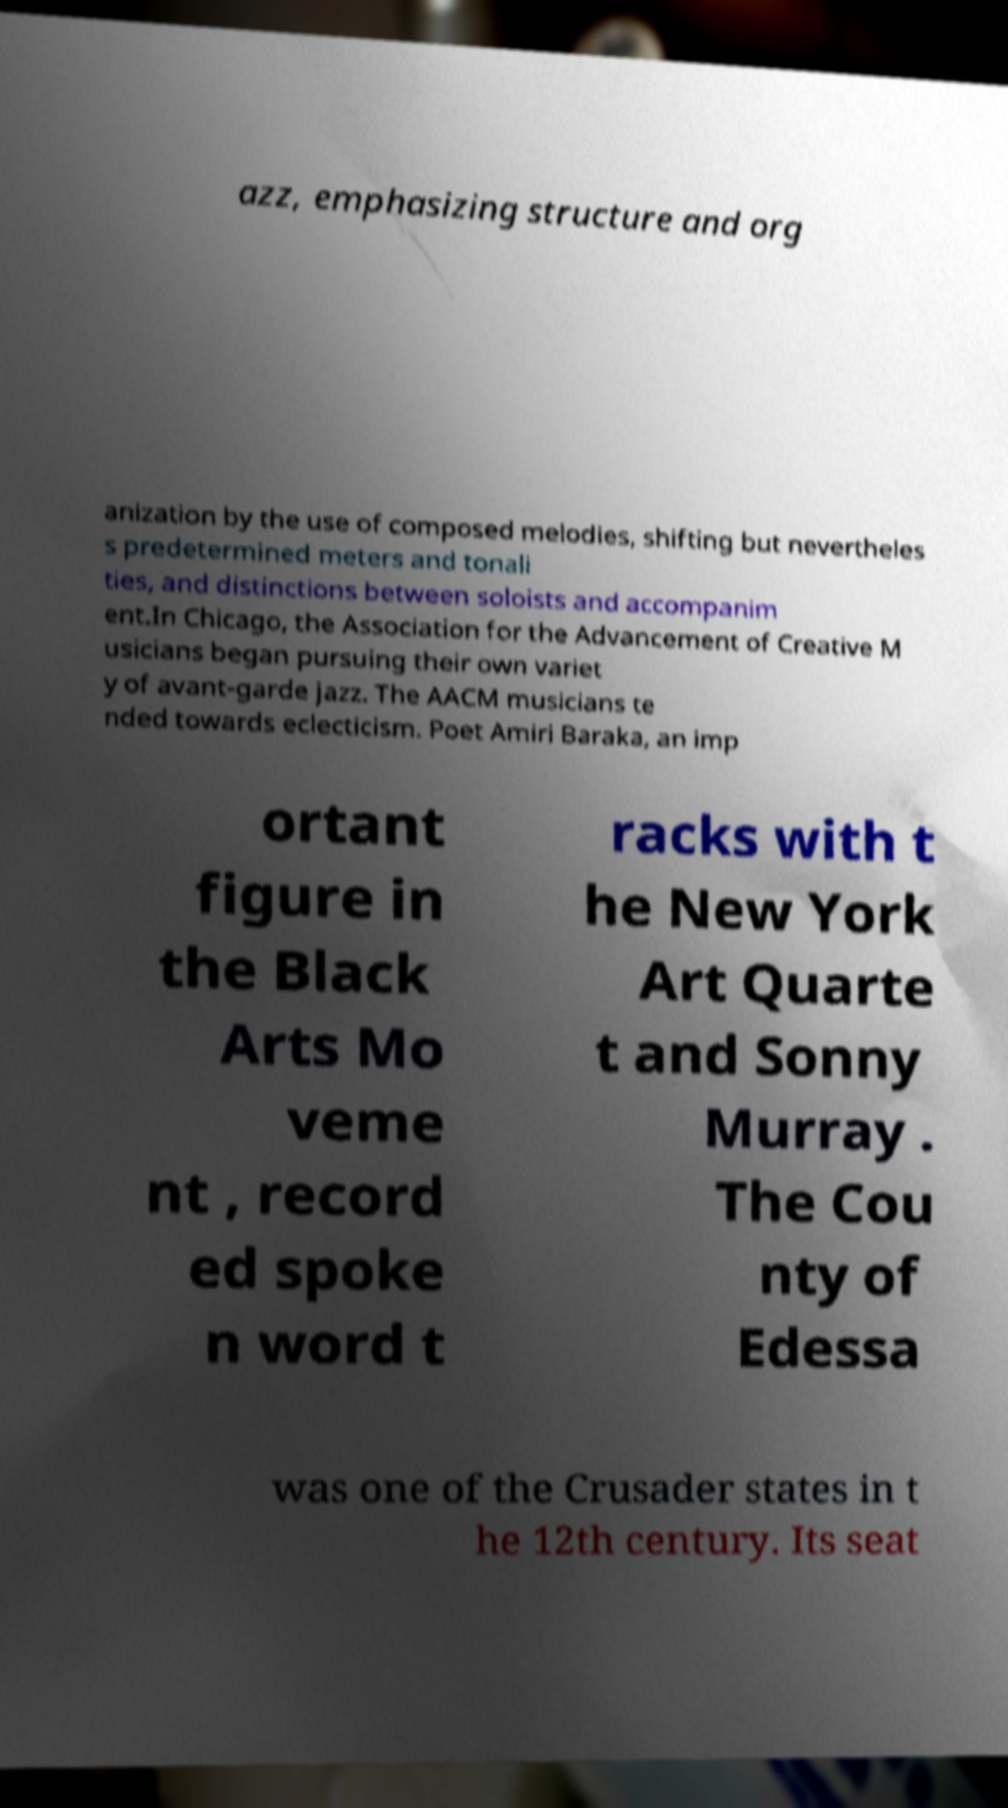Can you read and provide the text displayed in the image?This photo seems to have some interesting text. Can you extract and type it out for me? azz, emphasizing structure and org anization by the use of composed melodies, shifting but nevertheles s predetermined meters and tonali ties, and distinctions between soloists and accompanim ent.In Chicago, the Association for the Advancement of Creative M usicians began pursuing their own variet y of avant-garde jazz. The AACM musicians te nded towards eclecticism. Poet Amiri Baraka, an imp ortant figure in the Black Arts Mo veme nt , record ed spoke n word t racks with t he New York Art Quarte t and Sonny Murray . The Cou nty of Edessa was one of the Crusader states in t he 12th century. Its seat 